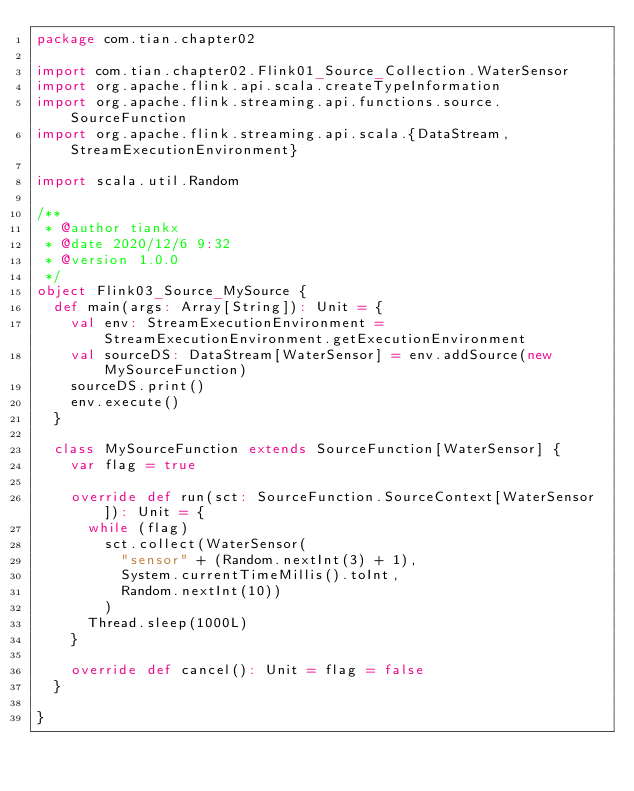Convert code to text. <code><loc_0><loc_0><loc_500><loc_500><_Scala_>package com.tian.chapter02

import com.tian.chapter02.Flink01_Source_Collection.WaterSensor
import org.apache.flink.api.scala.createTypeInformation
import org.apache.flink.streaming.api.functions.source.SourceFunction
import org.apache.flink.streaming.api.scala.{DataStream, StreamExecutionEnvironment}

import scala.util.Random

/**
 * @author tiankx
 * @date 2020/12/6 9:32
 * @version 1.0.0
 */
object Flink03_Source_MySource {
  def main(args: Array[String]): Unit = {
    val env: StreamExecutionEnvironment = StreamExecutionEnvironment.getExecutionEnvironment
    val sourceDS: DataStream[WaterSensor] = env.addSource(new MySourceFunction)
    sourceDS.print()
    env.execute()
  }

  class MySourceFunction extends SourceFunction[WaterSensor] {
    var flag = true

    override def run(sct: SourceFunction.SourceContext[WaterSensor]): Unit = {
      while (flag)
        sct.collect(WaterSensor(
          "sensor" + (Random.nextInt(3) + 1),
          System.currentTimeMillis().toInt,
          Random.nextInt(10))
        )
      Thread.sleep(1000L)
    }

    override def cancel(): Unit = flag = false
  }

}
</code> 